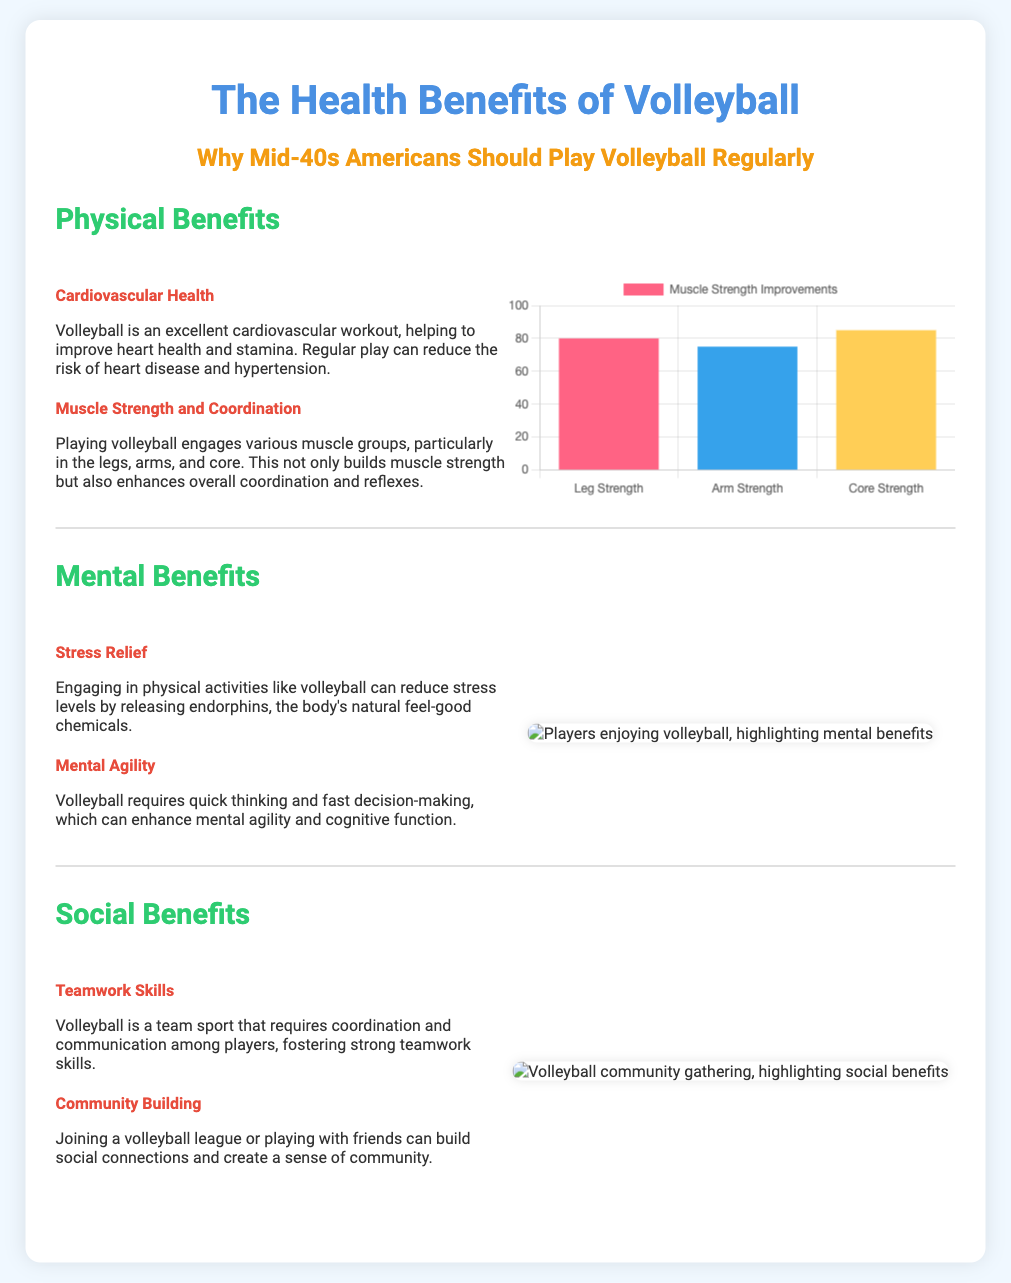What are the physical benefits of volleyball? The physical benefits listed in the document include cardiovascular health, muscle strength, and coordination.
Answer: Cardiovascular health, muscle strength, coordination What is the main mental benefit of playing volleyball? The document highlights stress relief and mental agility as the mental benefits.
Answer: Stress relief How many muscle strength improvements are shown in the chart? The chart displays improvements in leg strength, arm strength, and core strength, indicating three categories.
Answer: Three What is the color representing leg strength in the chart? The chart uses a specific color scheme, with leg strength represented by the first color in the dataset.
Answer: Pink What social benefit is associated with volleyball? The benefits discussed include teamwork skills and community building which emphasizes social interaction.
Answer: Teamwork skills Which organization is credited with the mental benefits image? The visual content under mental benefits is sourced from a specific website dedicated to mental health.
Answer: Mental Health Foundation What is the percentage for arm strength improvement indicated in the chart? The chart presents numerical data representing improvements in various muscle strengths, specifically for arm strength.
Answer: 75 What type of sport is volleyball? The document categorizes volleyball as a team sport which implies collaboration among players.
Answer: Team sport 